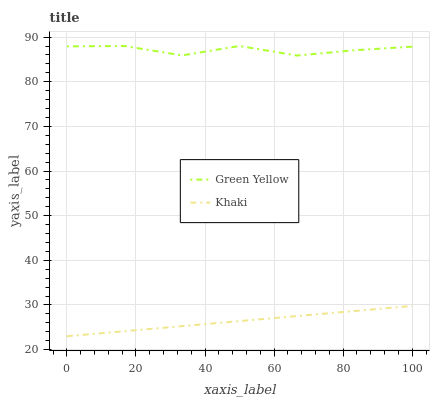Does Khaki have the minimum area under the curve?
Answer yes or no. Yes. Does Green Yellow have the maximum area under the curve?
Answer yes or no. Yes. Does Khaki have the maximum area under the curve?
Answer yes or no. No. Is Khaki the smoothest?
Answer yes or no. Yes. Is Green Yellow the roughest?
Answer yes or no. Yes. Is Khaki the roughest?
Answer yes or no. No. Does Khaki have the lowest value?
Answer yes or no. Yes. Does Green Yellow have the highest value?
Answer yes or no. Yes. Does Khaki have the highest value?
Answer yes or no. No. Is Khaki less than Green Yellow?
Answer yes or no. Yes. Is Green Yellow greater than Khaki?
Answer yes or no. Yes. Does Khaki intersect Green Yellow?
Answer yes or no. No. 